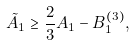<formula> <loc_0><loc_0><loc_500><loc_500>\tilde { A } _ { 1 } \geq \frac { 2 } { 3 } A _ { 1 } - B ^ { ( 3 ) } _ { 1 } ,</formula> 